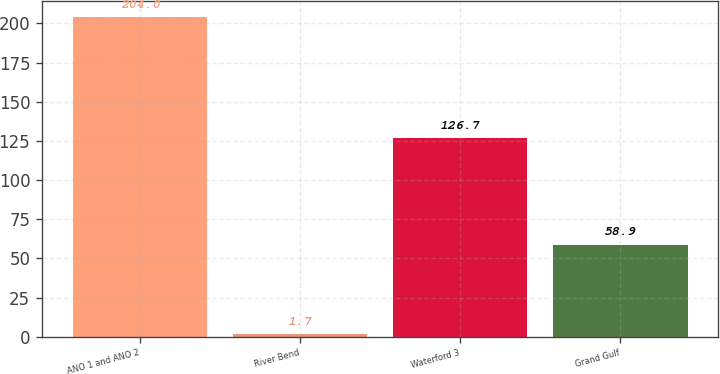Convert chart to OTSL. <chart><loc_0><loc_0><loc_500><loc_500><bar_chart><fcel>ANO 1 and ANO 2<fcel>River Bend<fcel>Waterford 3<fcel>Grand Gulf<nl><fcel>204<fcel>1.7<fcel>126.7<fcel>58.9<nl></chart> 